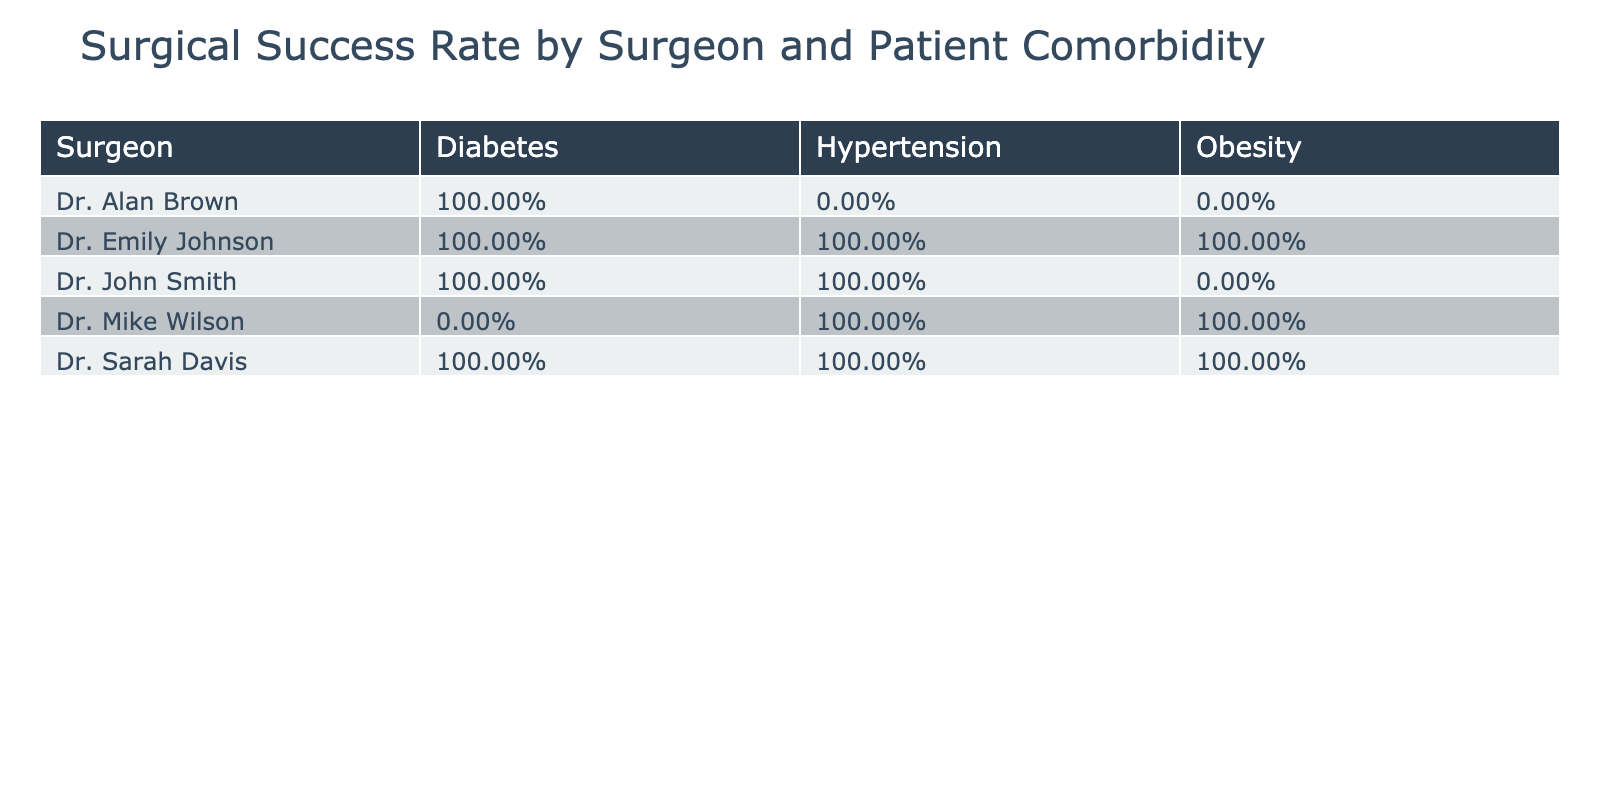What is the success rate for Dr. John Smith with patients having hypertension? According to the table, Dr. John Smith's record for patients with hypertension shows 1 successful surgery out of 1 case, leading to a success rate of 100%.
Answer: 100% Which surgeon had the highest success rate with diabetic patients? By examining the success rates for diabetic patients, Dr. Emily Johnson and Dr. Alan Brown both have 100% success rates (2 successes out of 2 cases for Dr. Emily and 1 success out of 1 case for Dr. Alan). However, Dr. Emily had more cases, thus demonstrating a higher level of experience with diabetic patients.
Answer: Dr. Emily Johnson Is there any surgeon who had a 100% success rate across all patient comorbidities? No surgeon achieved a 100% success rate for all comorbidities as every surgeon had at least one failure in their records for different comorbidities.
Answer: No What is the average success rate for surgeries performed by Dr. Mike Wilson? For Dr. Mike Wilson, there are 3 surgeries: 1 success and 2 failures. The success rate is calculated as 1 out of 3, which equals approximately 33.33%.
Answer: 33.33% Did any surgeon perform surgeries on patients with obesity and achieve a overall success rate of over 50%? Reviewing the data, Dr. John Smith and Dr. Mike Wilson both treated obesity patients. Dr. John had 1 success out of 1 surgery (100%), while Dr. Mike had 1 success out of 1 surgery (100%). Therefore, both surgeons qualify with over 50% success rate in surgeries involving obesity.
Answer: Yes What is the difference in the success rates between Dr. Sarah Davis and Dr. Alan Brown for the hypertension comorbidity? Dr. Sarah Davis had a success rate of 100% (1 success out of 1 surgery), while Dr. Alan Brown had a failure (0 successes out of 1 surgery), resulting in a difference of 100%.
Answer: 100% 